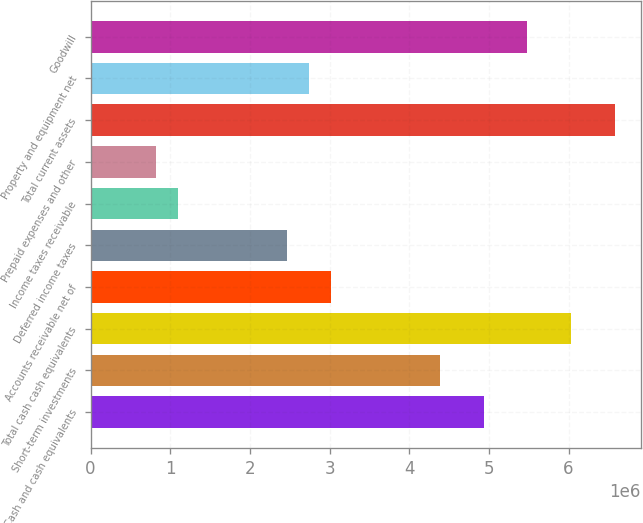Convert chart. <chart><loc_0><loc_0><loc_500><loc_500><bar_chart><fcel>Cash and cash equivalents<fcel>Short-term investments<fcel>Total cash cash equivalents<fcel>Accounts receivable net of<fcel>Deferred income taxes<fcel>Income taxes receivable<fcel>Prepaid expenses and other<fcel>Total current assets<fcel>Property and equipment net<fcel>Goodwill<nl><fcel>4.93533e+06<fcel>4.38711e+06<fcel>6.03175e+06<fcel>3.01658e+06<fcel>2.46837e+06<fcel>1.09784e+06<fcel>823736<fcel>6.57996e+06<fcel>2.74248e+06<fcel>5.48354e+06<nl></chart> 